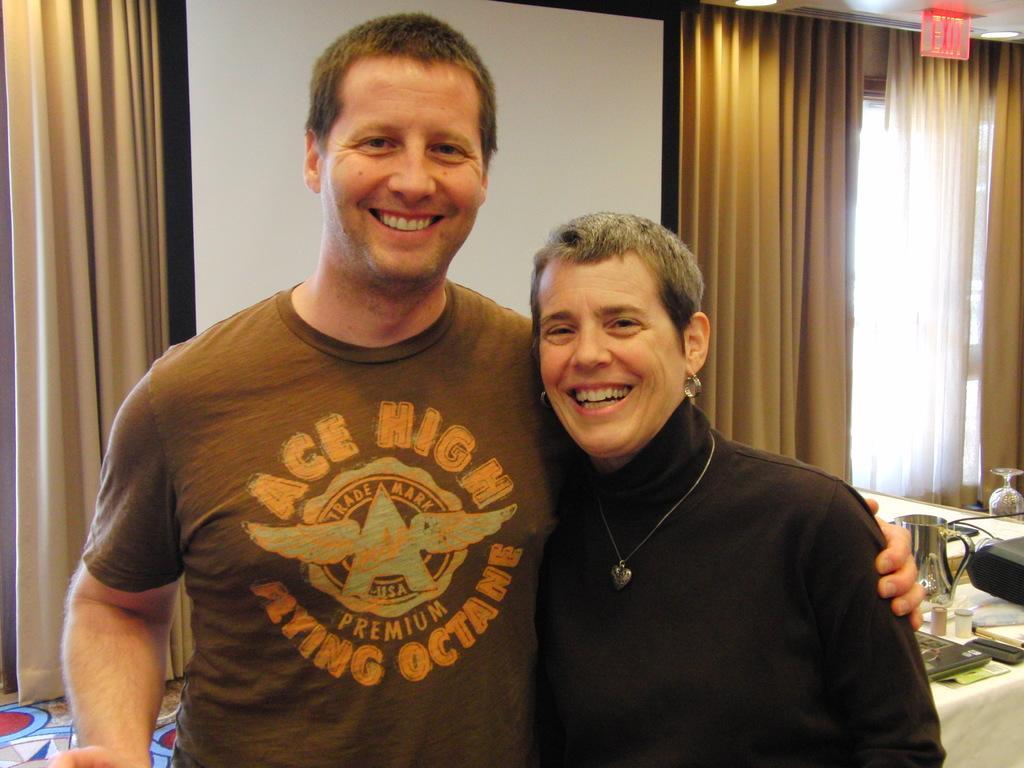How would you summarize this image in a sentence or two? In this image I can see two persons standing. The person at right is wearing black color shirt and the person at left is wearing brown color shirt. In the background I can see the jug and few objects on the table, few curtains and the projection screen. 